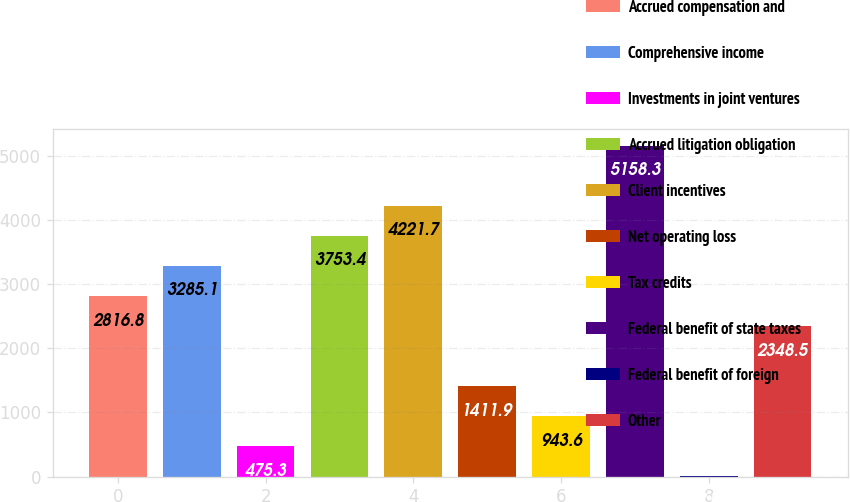Convert chart to OTSL. <chart><loc_0><loc_0><loc_500><loc_500><bar_chart><fcel>Accrued compensation and<fcel>Comprehensive income<fcel>Investments in joint ventures<fcel>Accrued litigation obligation<fcel>Client incentives<fcel>Net operating loss<fcel>Tax credits<fcel>Federal benefit of state taxes<fcel>Federal benefit of foreign<fcel>Other<nl><fcel>2816.8<fcel>3285.1<fcel>475.3<fcel>3753.4<fcel>4221.7<fcel>1411.9<fcel>943.6<fcel>5158.3<fcel>7<fcel>2348.5<nl></chart> 